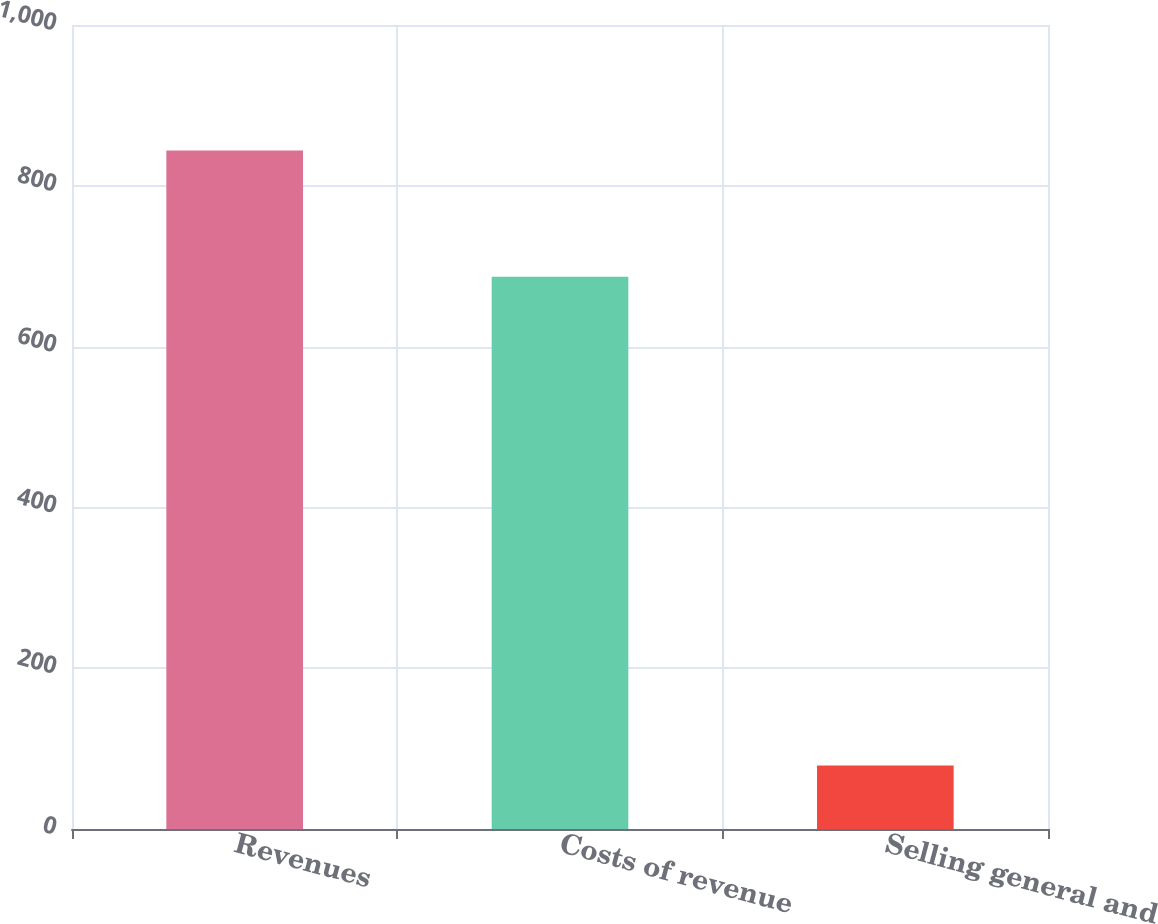Convert chart to OTSL. <chart><loc_0><loc_0><loc_500><loc_500><bar_chart><fcel>Revenues<fcel>Costs of revenue<fcel>Selling general and<nl><fcel>844<fcel>687<fcel>79<nl></chart> 